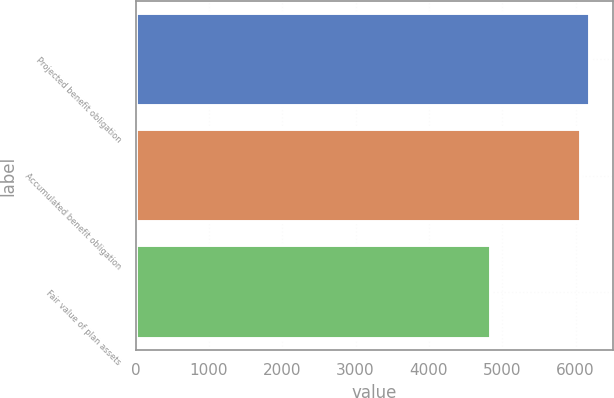<chart> <loc_0><loc_0><loc_500><loc_500><bar_chart><fcel>Projected benefit obligation<fcel>Accumulated benefit obligation<fcel>Fair value of plan assets<nl><fcel>6202<fcel>6079<fcel>4850<nl></chart> 